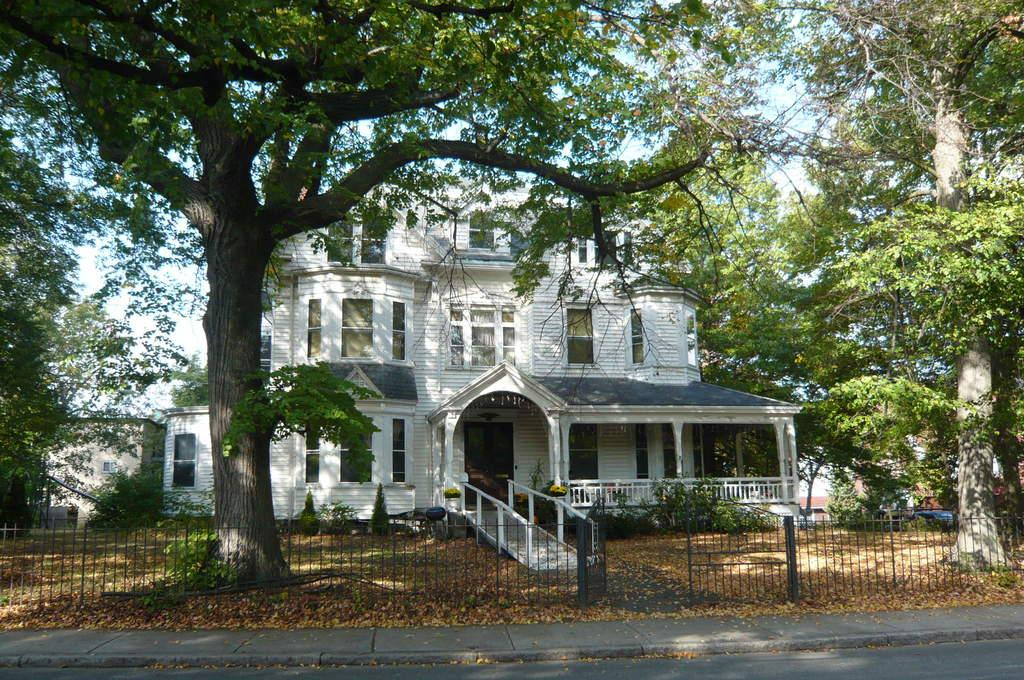What structure is the main subject of the image? There is a building in the image. What feature can be seen on the building? The building has a group of windows. What is located near the building in the image? There is a fence in the image. What can be seen in the background of the image? There is a group of trees and the sky visible in the background of the image. How many kittens are playing on the fence in the image? There are no kittens present in the image; it only features a building, a group of windows, a fence, a group of trees, and the sky in the background. What thrilling act can be seen being performed on the building in the image? There is no thrilling act being performed on the building in the image; it is a static structure with a group of windows. 